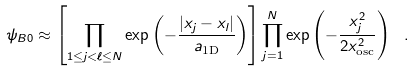<formula> <loc_0><loc_0><loc_500><loc_500>\psi _ { B 0 } \approx \left [ \prod _ { 1 \leq j < \ell \leq N } \exp \left ( - \frac { | x _ { j } - x _ { l } | } { a _ { \text {1D} } } \right ) \right ] \prod _ { j = 1 } ^ { N } \exp \left ( - \frac { x _ { j } ^ { 2 } } { 2 x _ { \text {osc} } ^ { 2 } } \right ) \ .</formula> 